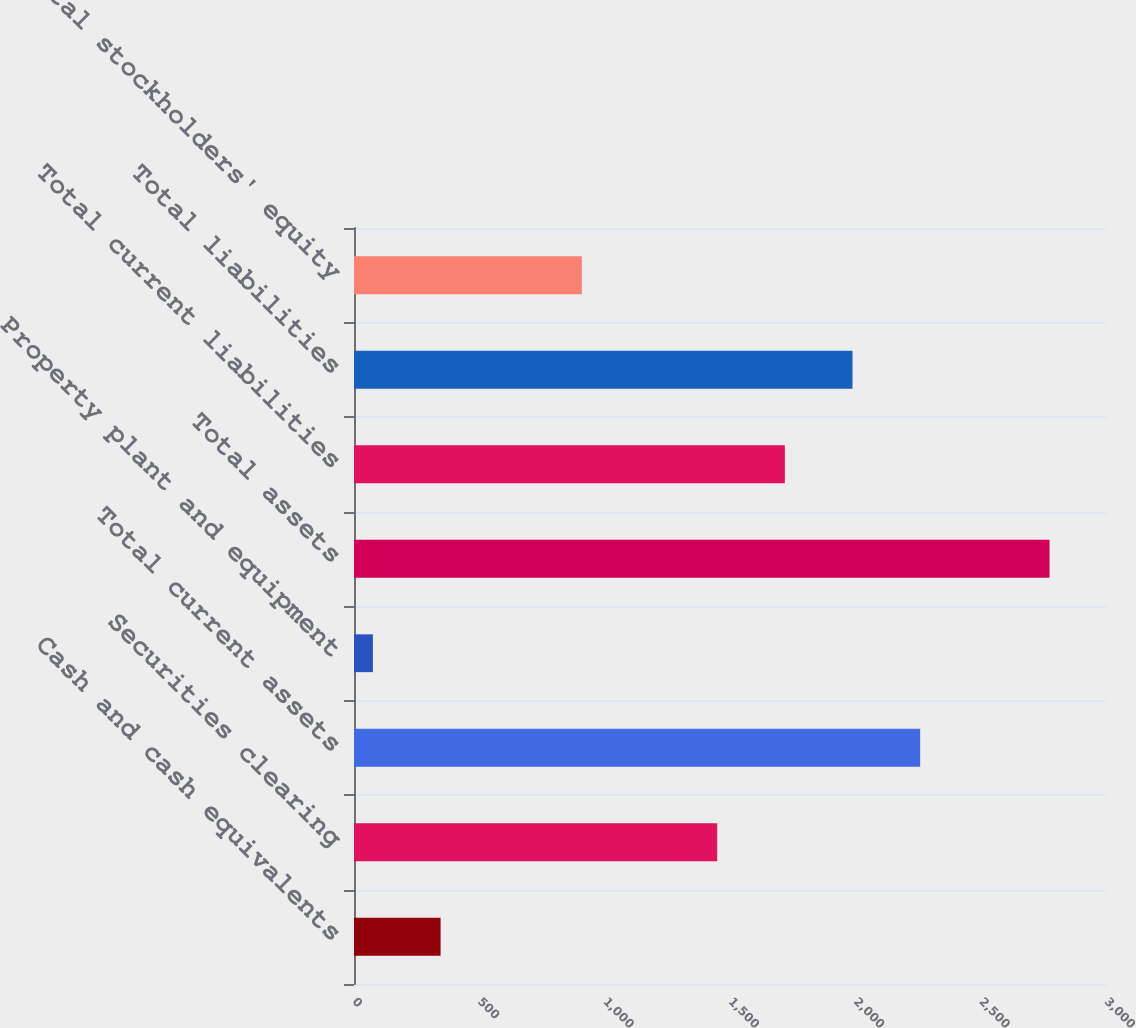Convert chart. <chart><loc_0><loc_0><loc_500><loc_500><bar_chart><fcel>Cash and cash equivalents<fcel>Securities clearing<fcel>Total current assets<fcel>Property plant and equipment<fcel>Total assets<fcel>Total current liabilities<fcel>Total liabilities<fcel>Total stockholders' equity<nl><fcel>345.33<fcel>1448.86<fcel>2258.65<fcel>75.4<fcel>2774.7<fcel>1718.79<fcel>1988.72<fcel>909<nl></chart> 